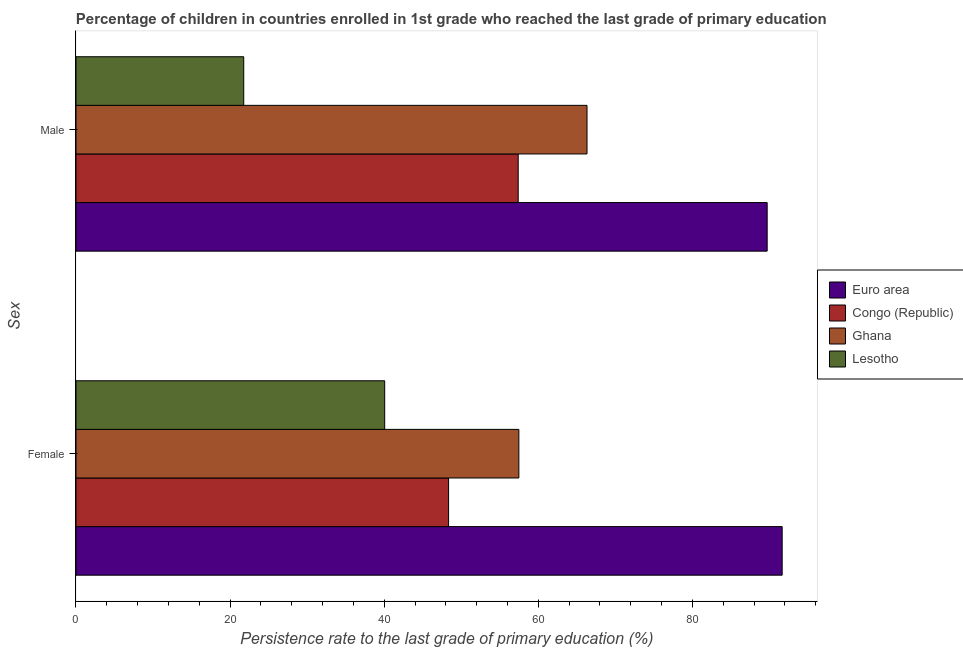How many different coloured bars are there?
Keep it short and to the point. 4. How many groups of bars are there?
Provide a succinct answer. 2. Are the number of bars per tick equal to the number of legend labels?
Your response must be concise. Yes. Are the number of bars on each tick of the Y-axis equal?
Give a very brief answer. Yes. How many bars are there on the 1st tick from the top?
Ensure brevity in your answer.  4. What is the persistence rate of male students in Ghana?
Your response must be concise. 66.33. Across all countries, what is the maximum persistence rate of female students?
Your answer should be compact. 91.65. Across all countries, what is the minimum persistence rate of female students?
Give a very brief answer. 40.07. In which country was the persistence rate of male students maximum?
Your response must be concise. Euro area. In which country was the persistence rate of male students minimum?
Ensure brevity in your answer.  Lesotho. What is the total persistence rate of female students in the graph?
Ensure brevity in your answer.  237.56. What is the difference between the persistence rate of female students in Congo (Republic) and that in Ghana?
Offer a very short reply. -9.12. What is the difference between the persistence rate of female students in Ghana and the persistence rate of male students in Congo (Republic)?
Ensure brevity in your answer.  0.09. What is the average persistence rate of male students per country?
Offer a very short reply. 58.8. What is the difference between the persistence rate of male students and persistence rate of female students in Euro area?
Provide a short and direct response. -1.95. In how many countries, is the persistence rate of female students greater than 68 %?
Provide a short and direct response. 1. What is the ratio of the persistence rate of male students in Lesotho to that in Euro area?
Keep it short and to the point. 0.24. Is the persistence rate of female students in Ghana less than that in Euro area?
Your answer should be very brief. Yes. In how many countries, is the persistence rate of female students greater than the average persistence rate of female students taken over all countries?
Provide a succinct answer. 1. What does the 3rd bar from the top in Male represents?
Ensure brevity in your answer.  Congo (Republic). What does the 4th bar from the bottom in Male represents?
Your answer should be very brief. Lesotho. How many bars are there?
Provide a succinct answer. 8. How many countries are there in the graph?
Offer a very short reply. 4. Does the graph contain any zero values?
Your answer should be compact. No. Where does the legend appear in the graph?
Offer a terse response. Center right. What is the title of the graph?
Keep it short and to the point. Percentage of children in countries enrolled in 1st grade who reached the last grade of primary education. Does "Monaco" appear as one of the legend labels in the graph?
Provide a short and direct response. No. What is the label or title of the X-axis?
Ensure brevity in your answer.  Persistence rate to the last grade of primary education (%). What is the label or title of the Y-axis?
Give a very brief answer. Sex. What is the Persistence rate to the last grade of primary education (%) of Euro area in Female?
Your answer should be very brief. 91.65. What is the Persistence rate to the last grade of primary education (%) in Congo (Republic) in Female?
Ensure brevity in your answer.  48.36. What is the Persistence rate to the last grade of primary education (%) of Ghana in Female?
Ensure brevity in your answer.  57.48. What is the Persistence rate to the last grade of primary education (%) in Lesotho in Female?
Give a very brief answer. 40.07. What is the Persistence rate to the last grade of primary education (%) of Euro area in Male?
Your answer should be very brief. 89.71. What is the Persistence rate to the last grade of primary education (%) of Congo (Republic) in Male?
Offer a very short reply. 57.39. What is the Persistence rate to the last grade of primary education (%) of Ghana in Male?
Your response must be concise. 66.33. What is the Persistence rate to the last grade of primary education (%) in Lesotho in Male?
Ensure brevity in your answer.  21.77. Across all Sex, what is the maximum Persistence rate to the last grade of primary education (%) in Euro area?
Ensure brevity in your answer.  91.65. Across all Sex, what is the maximum Persistence rate to the last grade of primary education (%) in Congo (Republic)?
Your response must be concise. 57.39. Across all Sex, what is the maximum Persistence rate to the last grade of primary education (%) in Ghana?
Your answer should be compact. 66.33. Across all Sex, what is the maximum Persistence rate to the last grade of primary education (%) of Lesotho?
Your answer should be very brief. 40.07. Across all Sex, what is the minimum Persistence rate to the last grade of primary education (%) in Euro area?
Offer a terse response. 89.71. Across all Sex, what is the minimum Persistence rate to the last grade of primary education (%) of Congo (Republic)?
Ensure brevity in your answer.  48.36. Across all Sex, what is the minimum Persistence rate to the last grade of primary education (%) in Ghana?
Your response must be concise. 57.48. Across all Sex, what is the minimum Persistence rate to the last grade of primary education (%) of Lesotho?
Keep it short and to the point. 21.77. What is the total Persistence rate to the last grade of primary education (%) in Euro area in the graph?
Give a very brief answer. 181.36. What is the total Persistence rate to the last grade of primary education (%) in Congo (Republic) in the graph?
Ensure brevity in your answer.  105.75. What is the total Persistence rate to the last grade of primary education (%) of Ghana in the graph?
Provide a succinct answer. 123.81. What is the total Persistence rate to the last grade of primary education (%) in Lesotho in the graph?
Your response must be concise. 61.84. What is the difference between the Persistence rate to the last grade of primary education (%) of Euro area in Female and that in Male?
Make the answer very short. 1.95. What is the difference between the Persistence rate to the last grade of primary education (%) of Congo (Republic) in Female and that in Male?
Provide a short and direct response. -9.04. What is the difference between the Persistence rate to the last grade of primary education (%) of Ghana in Female and that in Male?
Give a very brief answer. -8.85. What is the difference between the Persistence rate to the last grade of primary education (%) of Lesotho in Female and that in Male?
Offer a terse response. 18.29. What is the difference between the Persistence rate to the last grade of primary education (%) of Euro area in Female and the Persistence rate to the last grade of primary education (%) of Congo (Republic) in Male?
Make the answer very short. 34.26. What is the difference between the Persistence rate to the last grade of primary education (%) of Euro area in Female and the Persistence rate to the last grade of primary education (%) of Ghana in Male?
Keep it short and to the point. 25.33. What is the difference between the Persistence rate to the last grade of primary education (%) of Euro area in Female and the Persistence rate to the last grade of primary education (%) of Lesotho in Male?
Provide a short and direct response. 69.88. What is the difference between the Persistence rate to the last grade of primary education (%) in Congo (Republic) in Female and the Persistence rate to the last grade of primary education (%) in Ghana in Male?
Your response must be concise. -17.97. What is the difference between the Persistence rate to the last grade of primary education (%) in Congo (Republic) in Female and the Persistence rate to the last grade of primary education (%) in Lesotho in Male?
Offer a very short reply. 26.59. What is the difference between the Persistence rate to the last grade of primary education (%) in Ghana in Female and the Persistence rate to the last grade of primary education (%) in Lesotho in Male?
Make the answer very short. 35.71. What is the average Persistence rate to the last grade of primary education (%) in Euro area per Sex?
Keep it short and to the point. 90.68. What is the average Persistence rate to the last grade of primary education (%) in Congo (Republic) per Sex?
Your response must be concise. 52.88. What is the average Persistence rate to the last grade of primary education (%) of Ghana per Sex?
Ensure brevity in your answer.  61.9. What is the average Persistence rate to the last grade of primary education (%) in Lesotho per Sex?
Make the answer very short. 30.92. What is the difference between the Persistence rate to the last grade of primary education (%) of Euro area and Persistence rate to the last grade of primary education (%) of Congo (Republic) in Female?
Ensure brevity in your answer.  43.3. What is the difference between the Persistence rate to the last grade of primary education (%) in Euro area and Persistence rate to the last grade of primary education (%) in Ghana in Female?
Your answer should be compact. 34.17. What is the difference between the Persistence rate to the last grade of primary education (%) in Euro area and Persistence rate to the last grade of primary education (%) in Lesotho in Female?
Your answer should be very brief. 51.59. What is the difference between the Persistence rate to the last grade of primary education (%) of Congo (Republic) and Persistence rate to the last grade of primary education (%) of Ghana in Female?
Keep it short and to the point. -9.12. What is the difference between the Persistence rate to the last grade of primary education (%) in Congo (Republic) and Persistence rate to the last grade of primary education (%) in Lesotho in Female?
Your answer should be very brief. 8.29. What is the difference between the Persistence rate to the last grade of primary education (%) in Ghana and Persistence rate to the last grade of primary education (%) in Lesotho in Female?
Your response must be concise. 17.41. What is the difference between the Persistence rate to the last grade of primary education (%) in Euro area and Persistence rate to the last grade of primary education (%) in Congo (Republic) in Male?
Your response must be concise. 32.31. What is the difference between the Persistence rate to the last grade of primary education (%) in Euro area and Persistence rate to the last grade of primary education (%) in Ghana in Male?
Provide a succinct answer. 23.38. What is the difference between the Persistence rate to the last grade of primary education (%) of Euro area and Persistence rate to the last grade of primary education (%) of Lesotho in Male?
Keep it short and to the point. 67.94. What is the difference between the Persistence rate to the last grade of primary education (%) of Congo (Republic) and Persistence rate to the last grade of primary education (%) of Ghana in Male?
Ensure brevity in your answer.  -8.93. What is the difference between the Persistence rate to the last grade of primary education (%) of Congo (Republic) and Persistence rate to the last grade of primary education (%) of Lesotho in Male?
Offer a very short reply. 35.62. What is the difference between the Persistence rate to the last grade of primary education (%) in Ghana and Persistence rate to the last grade of primary education (%) in Lesotho in Male?
Ensure brevity in your answer.  44.55. What is the ratio of the Persistence rate to the last grade of primary education (%) in Euro area in Female to that in Male?
Offer a very short reply. 1.02. What is the ratio of the Persistence rate to the last grade of primary education (%) of Congo (Republic) in Female to that in Male?
Give a very brief answer. 0.84. What is the ratio of the Persistence rate to the last grade of primary education (%) in Ghana in Female to that in Male?
Your answer should be compact. 0.87. What is the ratio of the Persistence rate to the last grade of primary education (%) in Lesotho in Female to that in Male?
Your answer should be compact. 1.84. What is the difference between the highest and the second highest Persistence rate to the last grade of primary education (%) in Euro area?
Your response must be concise. 1.95. What is the difference between the highest and the second highest Persistence rate to the last grade of primary education (%) in Congo (Republic)?
Provide a short and direct response. 9.04. What is the difference between the highest and the second highest Persistence rate to the last grade of primary education (%) in Ghana?
Offer a terse response. 8.85. What is the difference between the highest and the second highest Persistence rate to the last grade of primary education (%) in Lesotho?
Your answer should be very brief. 18.29. What is the difference between the highest and the lowest Persistence rate to the last grade of primary education (%) in Euro area?
Provide a succinct answer. 1.95. What is the difference between the highest and the lowest Persistence rate to the last grade of primary education (%) of Congo (Republic)?
Keep it short and to the point. 9.04. What is the difference between the highest and the lowest Persistence rate to the last grade of primary education (%) in Ghana?
Offer a very short reply. 8.85. What is the difference between the highest and the lowest Persistence rate to the last grade of primary education (%) of Lesotho?
Ensure brevity in your answer.  18.29. 